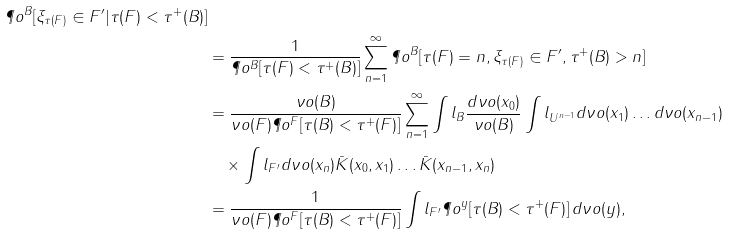Convert formula to latex. <formula><loc_0><loc_0><loc_500><loc_500>{ \P o ^ { B } [ \xi _ { \tau ( F ) } \in F ^ { \prime } | \tau ( F ) < \tau ^ { + } ( B ) ] } \\ & = \frac { 1 } { \P o ^ { B } [ \tau ( F ) < \tau ^ { + } ( B ) ] } \sum _ { n = 1 } ^ { \infty } \P o ^ { B } [ \tau ( F ) = n , \xi _ { \tau ( F ) } \in F ^ { \prime } , \tau ^ { + } ( B ) > n ] \\ & = \frac { \nu o ( B ) } { \nu o ( F ) \P o ^ { F } [ \tau ( B ) < \tau ^ { + } ( F ) ] } \sum _ { n = 1 } ^ { \infty } \int l _ { B } \frac { d \nu o ( x _ { 0 } ) } { \nu o ( B ) } \int l _ { U ^ { n - 1 } } d \nu o ( x _ { 1 } ) \dots d \nu o ( x _ { n - 1 } ) \\ & \quad \times \int l _ { F ^ { \prime } } d \nu o ( x _ { n } ) { \bar { K } } ( x _ { 0 } , x _ { 1 } ) \dots { \bar { K } } ( x _ { n - 1 } , x _ { n } ) \\ & = \frac { 1 } { \nu o ( F ) \P o ^ { F } [ \tau ( B ) < \tau ^ { + } ( F ) ] } \int l _ { F ^ { \prime } } \P o ^ { y } [ \tau ( B ) < \tau ^ { + } ( F ) ] \, d \nu o ( y ) ,</formula> 